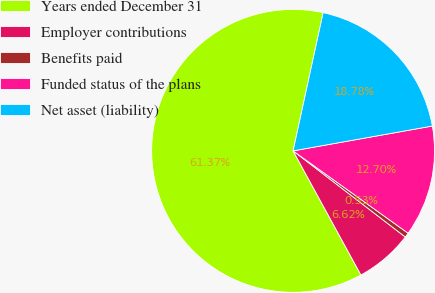Convert chart. <chart><loc_0><loc_0><loc_500><loc_500><pie_chart><fcel>Years ended December 31<fcel>Employer contributions<fcel>Benefits paid<fcel>Funded status of the plans<fcel>Net asset (liability)<nl><fcel>61.37%<fcel>6.62%<fcel>0.53%<fcel>12.7%<fcel>18.78%<nl></chart> 